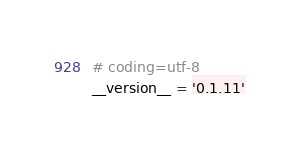Convert code to text. <code><loc_0><loc_0><loc_500><loc_500><_Python_># coding=utf-8
__version__ = '0.1.11'</code> 